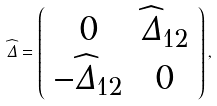<formula> <loc_0><loc_0><loc_500><loc_500>\widehat { \Delta } = \left ( \begin{array} { c c } 0 & \widehat { \Delta } _ { 1 2 } \\ - \widehat { \Delta } _ { 1 2 } & 0 \end{array} \right ) ,</formula> 